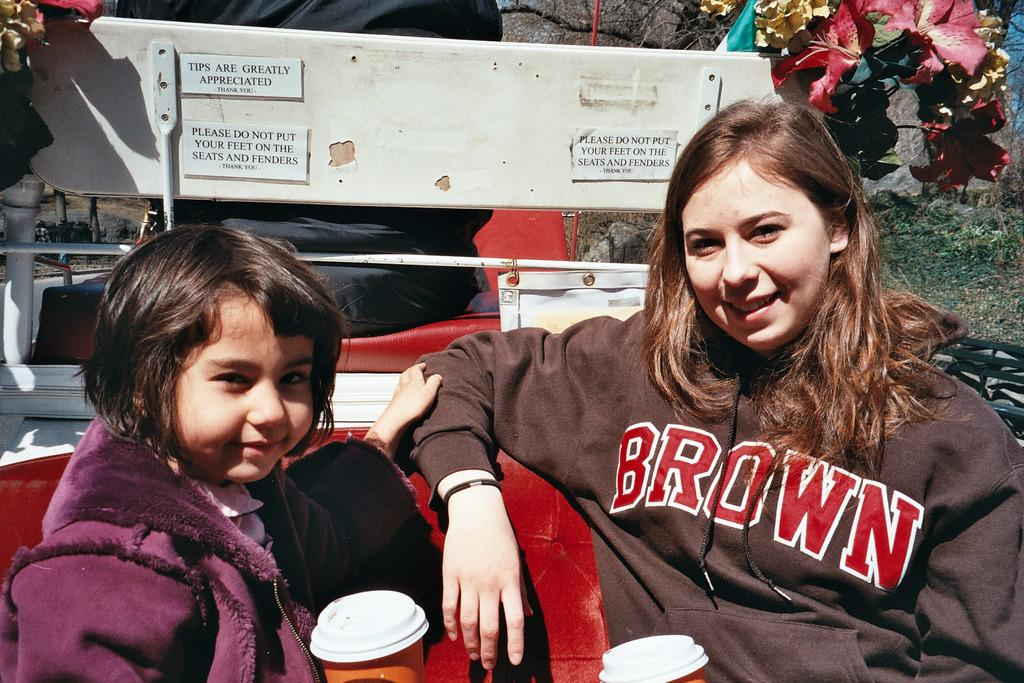<image>
Present a compact description of the photo's key features. Young ladies sitting in front of a display board with Tips are greatly appreciated in black letters. 